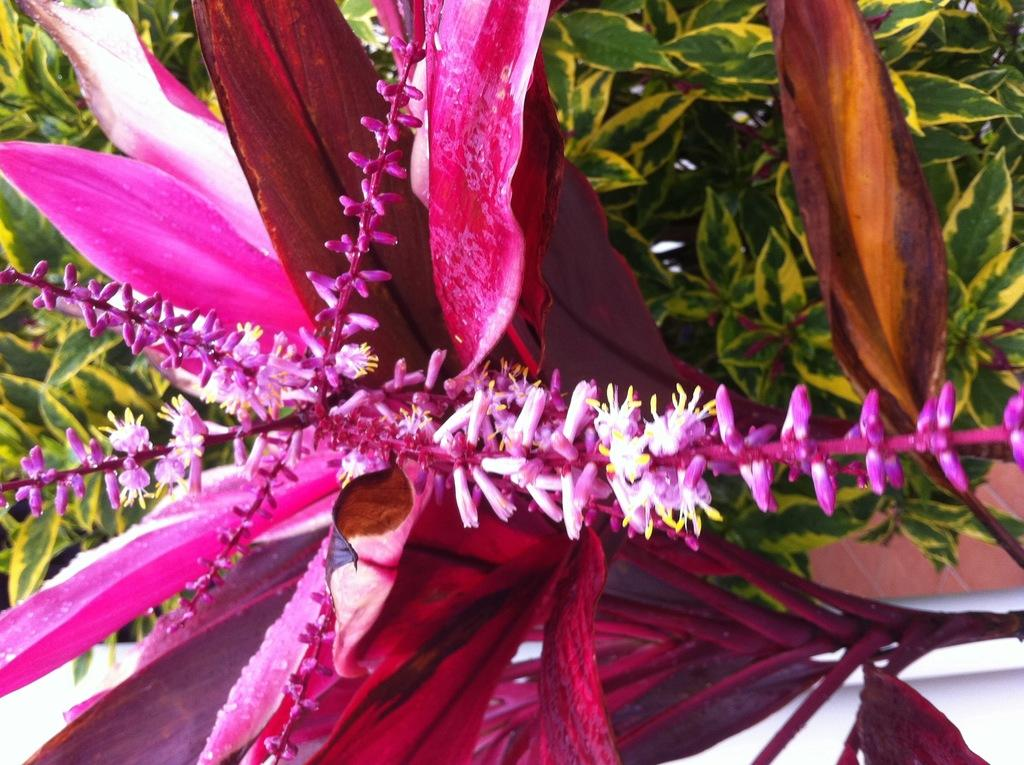What is the main subject in the foreground of the image? There is a pink flower in the foreground of the image. Is the flower part of a larger plant? Yes, the flower is on a plant. What can be seen in the background of the image? There are plants visible in the background of the image. What type of joke is being told by the wall in the image? There is no wall present in the image, and therefore no joke being told by a wall. 